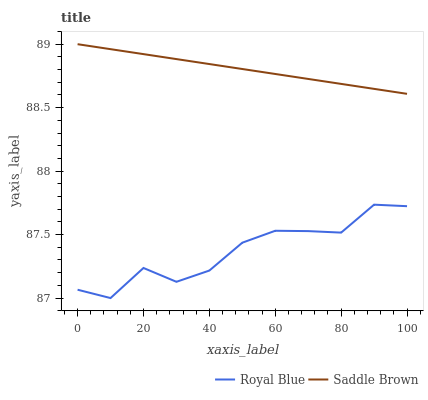Does Royal Blue have the minimum area under the curve?
Answer yes or no. Yes. Does Saddle Brown have the maximum area under the curve?
Answer yes or no. Yes. Does Saddle Brown have the minimum area under the curve?
Answer yes or no. No. Is Saddle Brown the smoothest?
Answer yes or no. Yes. Is Royal Blue the roughest?
Answer yes or no. Yes. Is Saddle Brown the roughest?
Answer yes or no. No. Does Royal Blue have the lowest value?
Answer yes or no. Yes. Does Saddle Brown have the lowest value?
Answer yes or no. No. Does Saddle Brown have the highest value?
Answer yes or no. Yes. Is Royal Blue less than Saddle Brown?
Answer yes or no. Yes. Is Saddle Brown greater than Royal Blue?
Answer yes or no. Yes. Does Royal Blue intersect Saddle Brown?
Answer yes or no. No. 